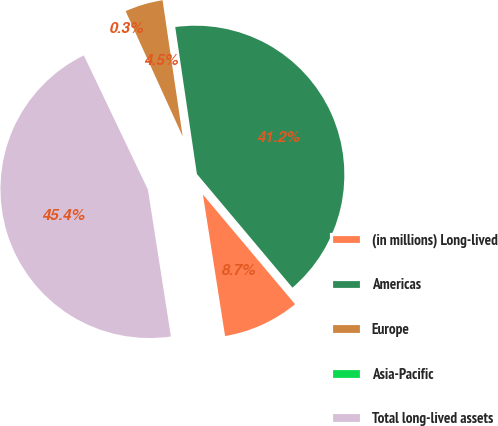Convert chart to OTSL. <chart><loc_0><loc_0><loc_500><loc_500><pie_chart><fcel>(in millions) Long-lived<fcel>Americas<fcel>Europe<fcel>Asia-Pacific<fcel>Total long-lived assets<nl><fcel>8.65%<fcel>41.2%<fcel>4.47%<fcel>0.29%<fcel>45.38%<nl></chart> 